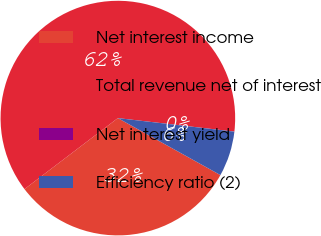Convert chart to OTSL. <chart><loc_0><loc_0><loc_500><loc_500><pie_chart><fcel>Net interest income<fcel>Total revenue net of interest<fcel>Net interest yield<fcel>Efficiency ratio (2)<nl><fcel>31.58%<fcel>62.19%<fcel>0.01%<fcel>6.23%<nl></chart> 